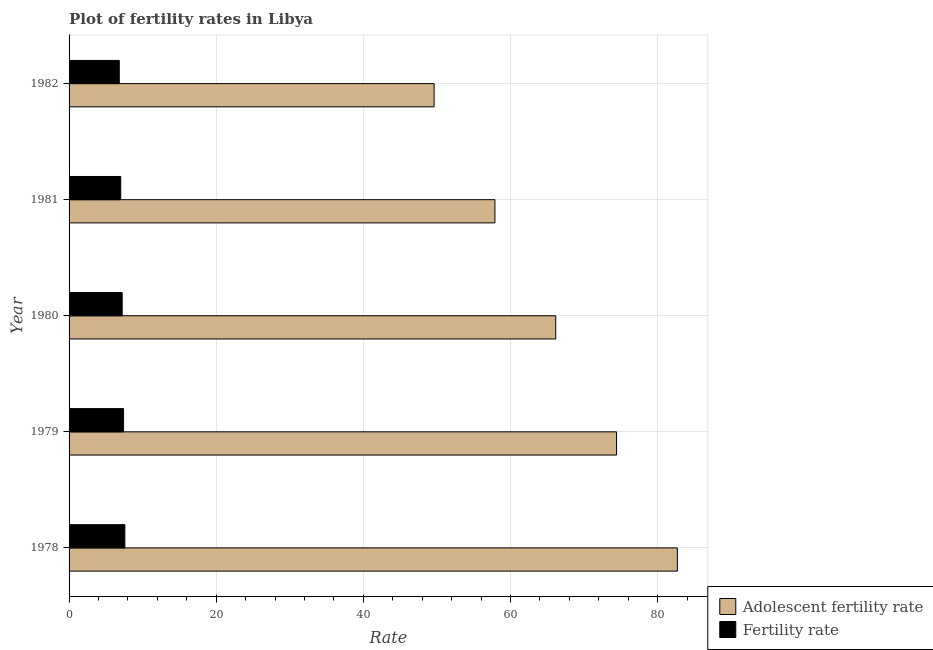How many different coloured bars are there?
Offer a very short reply. 2. How many groups of bars are there?
Provide a short and direct response. 5. Are the number of bars per tick equal to the number of legend labels?
Offer a terse response. Yes. How many bars are there on the 2nd tick from the top?
Give a very brief answer. 2. What is the label of the 5th group of bars from the top?
Your response must be concise. 1978. In how many cases, is the number of bars for a given year not equal to the number of legend labels?
Your answer should be very brief. 0. What is the adolescent fertility rate in 1981?
Ensure brevity in your answer.  57.89. Across all years, what is the maximum adolescent fertility rate?
Your response must be concise. 82.69. Across all years, what is the minimum adolescent fertility rate?
Provide a succinct answer. 49.62. In which year was the fertility rate maximum?
Your answer should be compact. 1978. In which year was the fertility rate minimum?
Offer a terse response. 1982. What is the total adolescent fertility rate in the graph?
Give a very brief answer. 330.78. What is the difference between the fertility rate in 1980 and that in 1982?
Your answer should be very brief. 0.39. What is the difference between the adolescent fertility rate in 1980 and the fertility rate in 1978?
Make the answer very short. 58.57. What is the average adolescent fertility rate per year?
Your response must be concise. 66.16. In the year 1978, what is the difference between the adolescent fertility rate and fertility rate?
Offer a very short reply. 75.11. In how many years, is the adolescent fertility rate greater than 36 ?
Provide a succinct answer. 5. What is the ratio of the fertility rate in 1981 to that in 1982?
Ensure brevity in your answer.  1.03. Is the adolescent fertility rate in 1979 less than that in 1981?
Provide a succinct answer. No. Is the difference between the adolescent fertility rate in 1978 and 1981 greater than the difference between the fertility rate in 1978 and 1981?
Provide a succinct answer. Yes. What is the difference between the highest and the second highest adolescent fertility rate?
Keep it short and to the point. 8.27. What is the difference between the highest and the lowest fertility rate?
Your answer should be very brief. 0.76. What does the 1st bar from the top in 1981 represents?
Provide a succinct answer. Fertility rate. What does the 1st bar from the bottom in 1978 represents?
Your answer should be very brief. Adolescent fertility rate. How many bars are there?
Give a very brief answer. 10. Are all the bars in the graph horizontal?
Offer a terse response. Yes. What is the difference between two consecutive major ticks on the X-axis?
Your answer should be compact. 20. Are the values on the major ticks of X-axis written in scientific E-notation?
Keep it short and to the point. No. Does the graph contain any zero values?
Your response must be concise. No. Does the graph contain grids?
Your answer should be compact. Yes. How many legend labels are there?
Your response must be concise. 2. How are the legend labels stacked?
Your answer should be compact. Vertical. What is the title of the graph?
Your answer should be compact. Plot of fertility rates in Libya. Does "Canada" appear as one of the legend labels in the graph?
Make the answer very short. No. What is the label or title of the X-axis?
Give a very brief answer. Rate. What is the label or title of the Y-axis?
Ensure brevity in your answer.  Year. What is the Rate in Adolescent fertility rate in 1978?
Provide a succinct answer. 82.69. What is the Rate in Fertility rate in 1978?
Offer a very short reply. 7.58. What is the Rate in Adolescent fertility rate in 1979?
Offer a very short reply. 74.42. What is the Rate of Fertility rate in 1979?
Your answer should be very brief. 7.41. What is the Rate of Adolescent fertility rate in 1980?
Your response must be concise. 66.16. What is the Rate in Fertility rate in 1980?
Provide a short and direct response. 7.22. What is the Rate of Adolescent fertility rate in 1981?
Your answer should be compact. 57.89. What is the Rate in Fertility rate in 1981?
Offer a terse response. 7.02. What is the Rate of Adolescent fertility rate in 1982?
Give a very brief answer. 49.62. What is the Rate in Fertility rate in 1982?
Keep it short and to the point. 6.83. Across all years, what is the maximum Rate of Adolescent fertility rate?
Offer a terse response. 82.69. Across all years, what is the maximum Rate of Fertility rate?
Your answer should be compact. 7.58. Across all years, what is the minimum Rate in Adolescent fertility rate?
Your answer should be compact. 49.62. Across all years, what is the minimum Rate in Fertility rate?
Offer a terse response. 6.83. What is the total Rate of Adolescent fertility rate in the graph?
Provide a short and direct response. 330.78. What is the total Rate in Fertility rate in the graph?
Keep it short and to the point. 36.06. What is the difference between the Rate of Adolescent fertility rate in 1978 and that in 1979?
Give a very brief answer. 8.27. What is the difference between the Rate of Fertility rate in 1978 and that in 1979?
Offer a terse response. 0.17. What is the difference between the Rate of Adolescent fertility rate in 1978 and that in 1980?
Offer a terse response. 16.53. What is the difference between the Rate in Fertility rate in 1978 and that in 1980?
Your response must be concise. 0.36. What is the difference between the Rate of Adolescent fertility rate in 1978 and that in 1981?
Keep it short and to the point. 24.8. What is the difference between the Rate of Fertility rate in 1978 and that in 1981?
Your answer should be compact. 0.56. What is the difference between the Rate of Adolescent fertility rate in 1978 and that in 1982?
Provide a succinct answer. 33.07. What is the difference between the Rate in Fertility rate in 1978 and that in 1982?
Ensure brevity in your answer.  0.76. What is the difference between the Rate of Adolescent fertility rate in 1979 and that in 1980?
Make the answer very short. 8.27. What is the difference between the Rate in Fertility rate in 1979 and that in 1980?
Offer a terse response. 0.19. What is the difference between the Rate of Adolescent fertility rate in 1979 and that in 1981?
Make the answer very short. 16.53. What is the difference between the Rate of Fertility rate in 1979 and that in 1981?
Your answer should be very brief. 0.39. What is the difference between the Rate in Adolescent fertility rate in 1979 and that in 1982?
Your response must be concise. 24.8. What is the difference between the Rate of Fertility rate in 1979 and that in 1982?
Provide a succinct answer. 0.58. What is the difference between the Rate in Adolescent fertility rate in 1980 and that in 1981?
Your answer should be compact. 8.27. What is the difference between the Rate of Fertility rate in 1980 and that in 1981?
Make the answer very short. 0.2. What is the difference between the Rate in Adolescent fertility rate in 1980 and that in 1982?
Provide a short and direct response. 16.53. What is the difference between the Rate of Fertility rate in 1980 and that in 1982?
Provide a succinct answer. 0.39. What is the difference between the Rate in Adolescent fertility rate in 1981 and that in 1982?
Make the answer very short. 8.27. What is the difference between the Rate in Fertility rate in 1981 and that in 1982?
Make the answer very short. 0.2. What is the difference between the Rate of Adolescent fertility rate in 1978 and the Rate of Fertility rate in 1979?
Offer a terse response. 75.28. What is the difference between the Rate in Adolescent fertility rate in 1978 and the Rate in Fertility rate in 1980?
Provide a succinct answer. 75.47. What is the difference between the Rate in Adolescent fertility rate in 1978 and the Rate in Fertility rate in 1981?
Ensure brevity in your answer.  75.67. What is the difference between the Rate in Adolescent fertility rate in 1978 and the Rate in Fertility rate in 1982?
Make the answer very short. 75.86. What is the difference between the Rate of Adolescent fertility rate in 1979 and the Rate of Fertility rate in 1980?
Give a very brief answer. 67.2. What is the difference between the Rate of Adolescent fertility rate in 1979 and the Rate of Fertility rate in 1981?
Provide a short and direct response. 67.4. What is the difference between the Rate of Adolescent fertility rate in 1979 and the Rate of Fertility rate in 1982?
Provide a succinct answer. 67.6. What is the difference between the Rate of Adolescent fertility rate in 1980 and the Rate of Fertility rate in 1981?
Keep it short and to the point. 59.13. What is the difference between the Rate of Adolescent fertility rate in 1980 and the Rate of Fertility rate in 1982?
Make the answer very short. 59.33. What is the difference between the Rate of Adolescent fertility rate in 1981 and the Rate of Fertility rate in 1982?
Offer a very short reply. 51.06. What is the average Rate of Adolescent fertility rate per year?
Your answer should be very brief. 66.16. What is the average Rate in Fertility rate per year?
Keep it short and to the point. 7.21. In the year 1978, what is the difference between the Rate in Adolescent fertility rate and Rate in Fertility rate?
Offer a very short reply. 75.11. In the year 1979, what is the difference between the Rate of Adolescent fertility rate and Rate of Fertility rate?
Your answer should be compact. 67.02. In the year 1980, what is the difference between the Rate in Adolescent fertility rate and Rate in Fertility rate?
Ensure brevity in your answer.  58.94. In the year 1981, what is the difference between the Rate of Adolescent fertility rate and Rate of Fertility rate?
Offer a very short reply. 50.87. In the year 1982, what is the difference between the Rate in Adolescent fertility rate and Rate in Fertility rate?
Keep it short and to the point. 42.8. What is the ratio of the Rate of Fertility rate in 1978 to that in 1979?
Your answer should be very brief. 1.02. What is the ratio of the Rate in Adolescent fertility rate in 1978 to that in 1980?
Make the answer very short. 1.25. What is the ratio of the Rate in Fertility rate in 1978 to that in 1980?
Give a very brief answer. 1.05. What is the ratio of the Rate in Adolescent fertility rate in 1978 to that in 1981?
Offer a very short reply. 1.43. What is the ratio of the Rate in Fertility rate in 1978 to that in 1981?
Your response must be concise. 1.08. What is the ratio of the Rate of Adolescent fertility rate in 1978 to that in 1982?
Offer a very short reply. 1.67. What is the ratio of the Rate in Fertility rate in 1978 to that in 1982?
Provide a succinct answer. 1.11. What is the ratio of the Rate of Adolescent fertility rate in 1979 to that in 1980?
Offer a terse response. 1.12. What is the ratio of the Rate of Fertility rate in 1979 to that in 1980?
Your answer should be very brief. 1.03. What is the ratio of the Rate of Adolescent fertility rate in 1979 to that in 1981?
Ensure brevity in your answer.  1.29. What is the ratio of the Rate of Fertility rate in 1979 to that in 1981?
Provide a succinct answer. 1.05. What is the ratio of the Rate in Adolescent fertility rate in 1979 to that in 1982?
Give a very brief answer. 1.5. What is the ratio of the Rate in Fertility rate in 1979 to that in 1982?
Your answer should be compact. 1.09. What is the ratio of the Rate in Adolescent fertility rate in 1980 to that in 1981?
Make the answer very short. 1.14. What is the ratio of the Rate in Fertility rate in 1980 to that in 1981?
Offer a very short reply. 1.03. What is the ratio of the Rate in Adolescent fertility rate in 1980 to that in 1982?
Your response must be concise. 1.33. What is the ratio of the Rate in Fertility rate in 1980 to that in 1982?
Provide a short and direct response. 1.06. What is the ratio of the Rate of Adolescent fertility rate in 1981 to that in 1982?
Offer a terse response. 1.17. What is the ratio of the Rate in Fertility rate in 1981 to that in 1982?
Your answer should be compact. 1.03. What is the difference between the highest and the second highest Rate of Adolescent fertility rate?
Offer a very short reply. 8.27. What is the difference between the highest and the second highest Rate of Fertility rate?
Offer a very short reply. 0.17. What is the difference between the highest and the lowest Rate of Adolescent fertility rate?
Your answer should be very brief. 33.07. What is the difference between the highest and the lowest Rate in Fertility rate?
Make the answer very short. 0.76. 